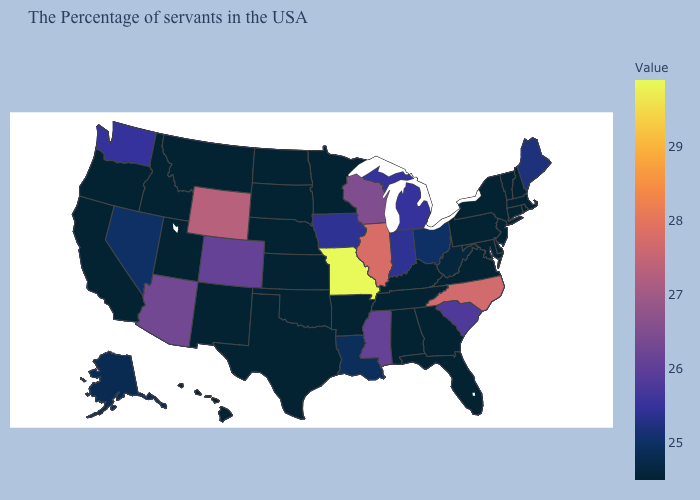Is the legend a continuous bar?
Short answer required. Yes. Does the map have missing data?
Give a very brief answer. No. Does the map have missing data?
Write a very short answer. No. Does Oklahoma have the lowest value in the USA?
Quick response, please. Yes. Which states have the highest value in the USA?
Keep it brief. Missouri. Which states have the highest value in the USA?
Quick response, please. Missouri. Does Virginia have the highest value in the South?
Short answer required. No. 